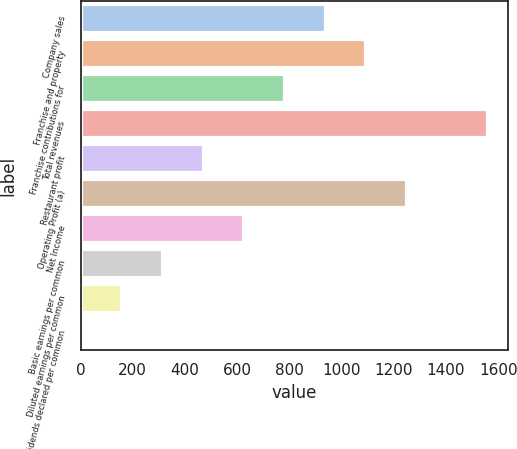Convert chart. <chart><loc_0><loc_0><loc_500><loc_500><bar_chart><fcel>Company sales<fcel>Franchise and property<fcel>Franchise contributions for<fcel>Total revenues<fcel>Restaurant profit<fcel>Operating Profit (a)<fcel>Net Income<fcel>Basic earnings per common<fcel>Diluted earnings per common<fcel>Dividends declared per common<nl><fcel>934.92<fcel>1090.68<fcel>779.16<fcel>1558<fcel>467.64<fcel>1246.44<fcel>623.4<fcel>311.88<fcel>156.12<fcel>0.36<nl></chart> 